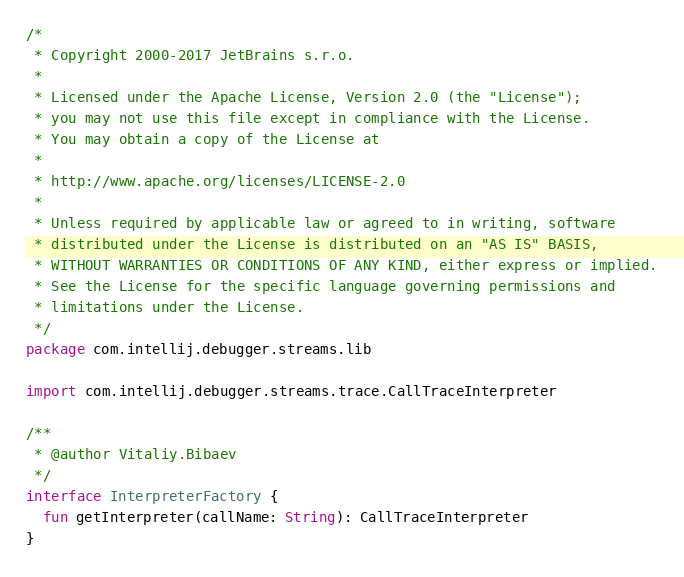<code> <loc_0><loc_0><loc_500><loc_500><_Kotlin_>/*
 * Copyright 2000-2017 JetBrains s.r.o.
 *
 * Licensed under the Apache License, Version 2.0 (the "License");
 * you may not use this file except in compliance with the License.
 * You may obtain a copy of the License at
 *
 * http://www.apache.org/licenses/LICENSE-2.0
 *
 * Unless required by applicable law or agreed to in writing, software
 * distributed under the License is distributed on an "AS IS" BASIS,
 * WITHOUT WARRANTIES OR CONDITIONS OF ANY KIND, either express or implied.
 * See the License for the specific language governing permissions and
 * limitations under the License.
 */
package com.intellij.debugger.streams.lib

import com.intellij.debugger.streams.trace.CallTraceInterpreter

/**
 * @author Vitaliy.Bibaev
 */
interface InterpreterFactory {
  fun getInterpreter(callName: String): CallTraceInterpreter
}</code> 